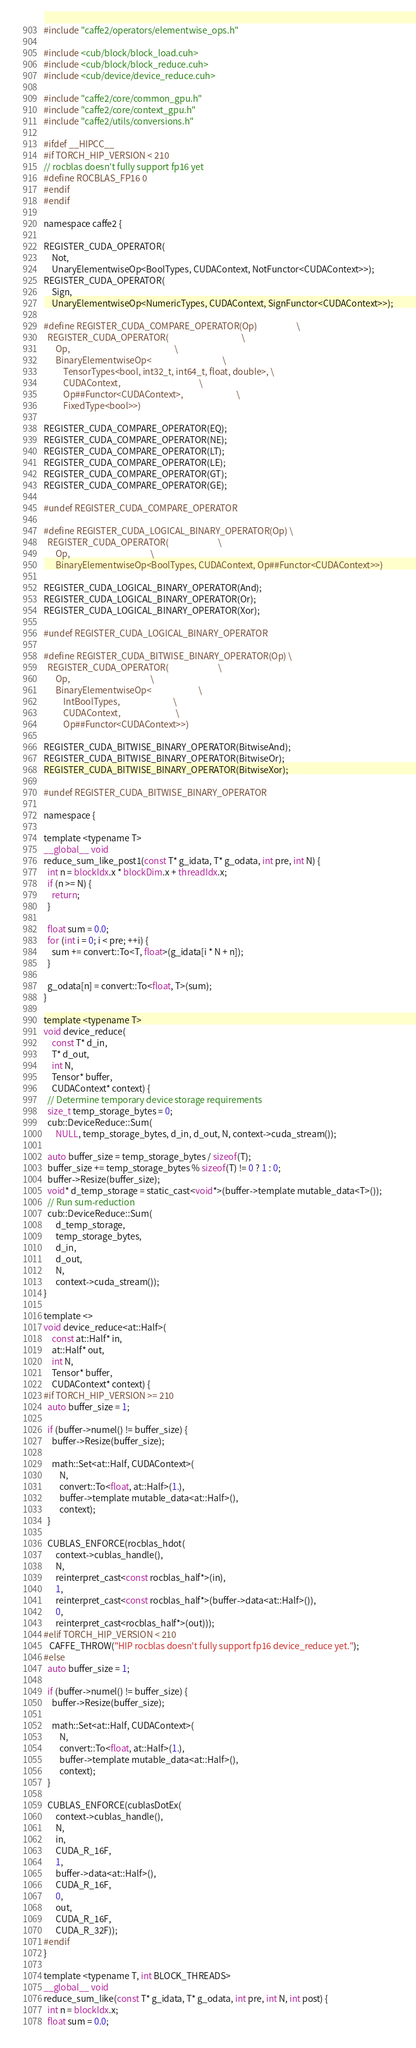<code> <loc_0><loc_0><loc_500><loc_500><_Cuda_>#include "caffe2/operators/elementwise_ops.h"

#include <cub/block/block_load.cuh>
#include <cub/block/block_reduce.cuh>
#include <cub/device/device_reduce.cuh>

#include "caffe2/core/common_gpu.h"
#include "caffe2/core/context_gpu.h"
#include "caffe2/utils/conversions.h"

#ifdef __HIPCC__
#if TORCH_HIP_VERSION < 210
// rocblas doesn't fully support fp16 yet
#define ROCBLAS_FP16 0
#endif
#endif

namespace caffe2 {

REGISTER_CUDA_OPERATOR(
    Not,
    UnaryElementwiseOp<BoolTypes, CUDAContext, NotFunctor<CUDAContext>>);
REGISTER_CUDA_OPERATOR(
    Sign,
    UnaryElementwiseOp<NumericTypes, CUDAContext, SignFunctor<CUDAContext>>);

#define REGISTER_CUDA_COMPARE_OPERATOR(Op)                    \
  REGISTER_CUDA_OPERATOR(                                     \
      Op,                                                     \
      BinaryElementwiseOp<                                    \
          TensorTypes<bool, int32_t, int64_t, float, double>, \
          CUDAContext,                                        \
          Op##Functor<CUDAContext>,                           \
          FixedType<bool>>)

REGISTER_CUDA_COMPARE_OPERATOR(EQ);
REGISTER_CUDA_COMPARE_OPERATOR(NE);
REGISTER_CUDA_COMPARE_OPERATOR(LT);
REGISTER_CUDA_COMPARE_OPERATOR(LE);
REGISTER_CUDA_COMPARE_OPERATOR(GT);
REGISTER_CUDA_COMPARE_OPERATOR(GE);

#undef REGISTER_CUDA_COMPARE_OPERATOR

#define REGISTER_CUDA_LOGICAL_BINARY_OPERATOR(Op) \
  REGISTER_CUDA_OPERATOR(                         \
      Op,                                         \
      BinaryElementwiseOp<BoolTypes, CUDAContext, Op##Functor<CUDAContext>>)

REGISTER_CUDA_LOGICAL_BINARY_OPERATOR(And);
REGISTER_CUDA_LOGICAL_BINARY_OPERATOR(Or);
REGISTER_CUDA_LOGICAL_BINARY_OPERATOR(Xor);

#undef REGISTER_CUDA_LOGICAL_BINARY_OPERATOR

#define REGISTER_CUDA_BITWISE_BINARY_OPERATOR(Op) \
  REGISTER_CUDA_OPERATOR(                         \
      Op,                                         \
      BinaryElementwiseOp<                        \
          IntBoolTypes,                           \
          CUDAContext,                            \
          Op##Functor<CUDAContext>>)

REGISTER_CUDA_BITWISE_BINARY_OPERATOR(BitwiseAnd);
REGISTER_CUDA_BITWISE_BINARY_OPERATOR(BitwiseOr);
REGISTER_CUDA_BITWISE_BINARY_OPERATOR(BitwiseXor);

#undef REGISTER_CUDA_BITWISE_BINARY_OPERATOR

namespace {

template <typename T>
__global__ void
reduce_sum_like_post1(const T* g_idata, T* g_odata, int pre, int N) {
  int n = blockIdx.x * blockDim.x + threadIdx.x;
  if (n >= N) {
    return;
  }

  float sum = 0.0;
  for (int i = 0; i < pre; ++i) {
    sum += convert::To<T, float>(g_idata[i * N + n]);
  }

  g_odata[n] = convert::To<float, T>(sum);
}

template <typename T>
void device_reduce(
    const T* d_in,
    T* d_out,
    int N,
    Tensor* buffer,
    CUDAContext* context) {
  // Determine temporary device storage requirements
  size_t temp_storage_bytes = 0;
  cub::DeviceReduce::Sum(
      NULL, temp_storage_bytes, d_in, d_out, N, context->cuda_stream());

  auto buffer_size = temp_storage_bytes / sizeof(T);
  buffer_size += temp_storage_bytes % sizeof(T) != 0 ? 1 : 0;
  buffer->Resize(buffer_size);
  void* d_temp_storage = static_cast<void*>(buffer->template mutable_data<T>());
  // Run sum-reduction
  cub::DeviceReduce::Sum(
      d_temp_storage,
      temp_storage_bytes,
      d_in,
      d_out,
      N,
      context->cuda_stream());
}

template <>
void device_reduce<at::Half>(
    const at::Half* in,
    at::Half* out,
    int N,
    Tensor* buffer,
    CUDAContext* context) {
#if TORCH_HIP_VERSION >= 210
  auto buffer_size = 1;

  if (buffer->numel() != buffer_size) {
    buffer->Resize(buffer_size);

    math::Set<at::Half, CUDAContext>(
        N,
        convert::To<float, at::Half>(1.),
        buffer->template mutable_data<at::Half>(),
        context);
  }

  CUBLAS_ENFORCE(rocblas_hdot(
      context->cublas_handle(),
      N,
      reinterpret_cast<const rocblas_half*>(in),
      1,
      reinterpret_cast<const rocblas_half*>(buffer->data<at::Half>()),
      0,
      reinterpret_cast<rocblas_half*>(out)));
#elif TORCH_HIP_VERSION < 210
   CAFFE_THROW("HIP rocblas doesn't fully support fp16 device_reduce yet.");
#else
  auto buffer_size = 1;

  if (buffer->numel() != buffer_size) {
    buffer->Resize(buffer_size);

    math::Set<at::Half, CUDAContext>(
        N,
        convert::To<float, at::Half>(1.),
        buffer->template mutable_data<at::Half>(),
        context);
  }

  CUBLAS_ENFORCE(cublasDotEx(
      context->cublas_handle(),
      N,
      in,
      CUDA_R_16F,
      1,
      buffer->data<at::Half>(),
      CUDA_R_16F,
      0,
      out,
      CUDA_R_16F,
      CUDA_R_32F));
#endif
}

template <typename T, int BLOCK_THREADS>
__global__ void
reduce_sum_like(const T* g_idata, T* g_odata, int pre, int N, int post) {
  int n = blockIdx.x;
  float sum = 0.0;</code> 